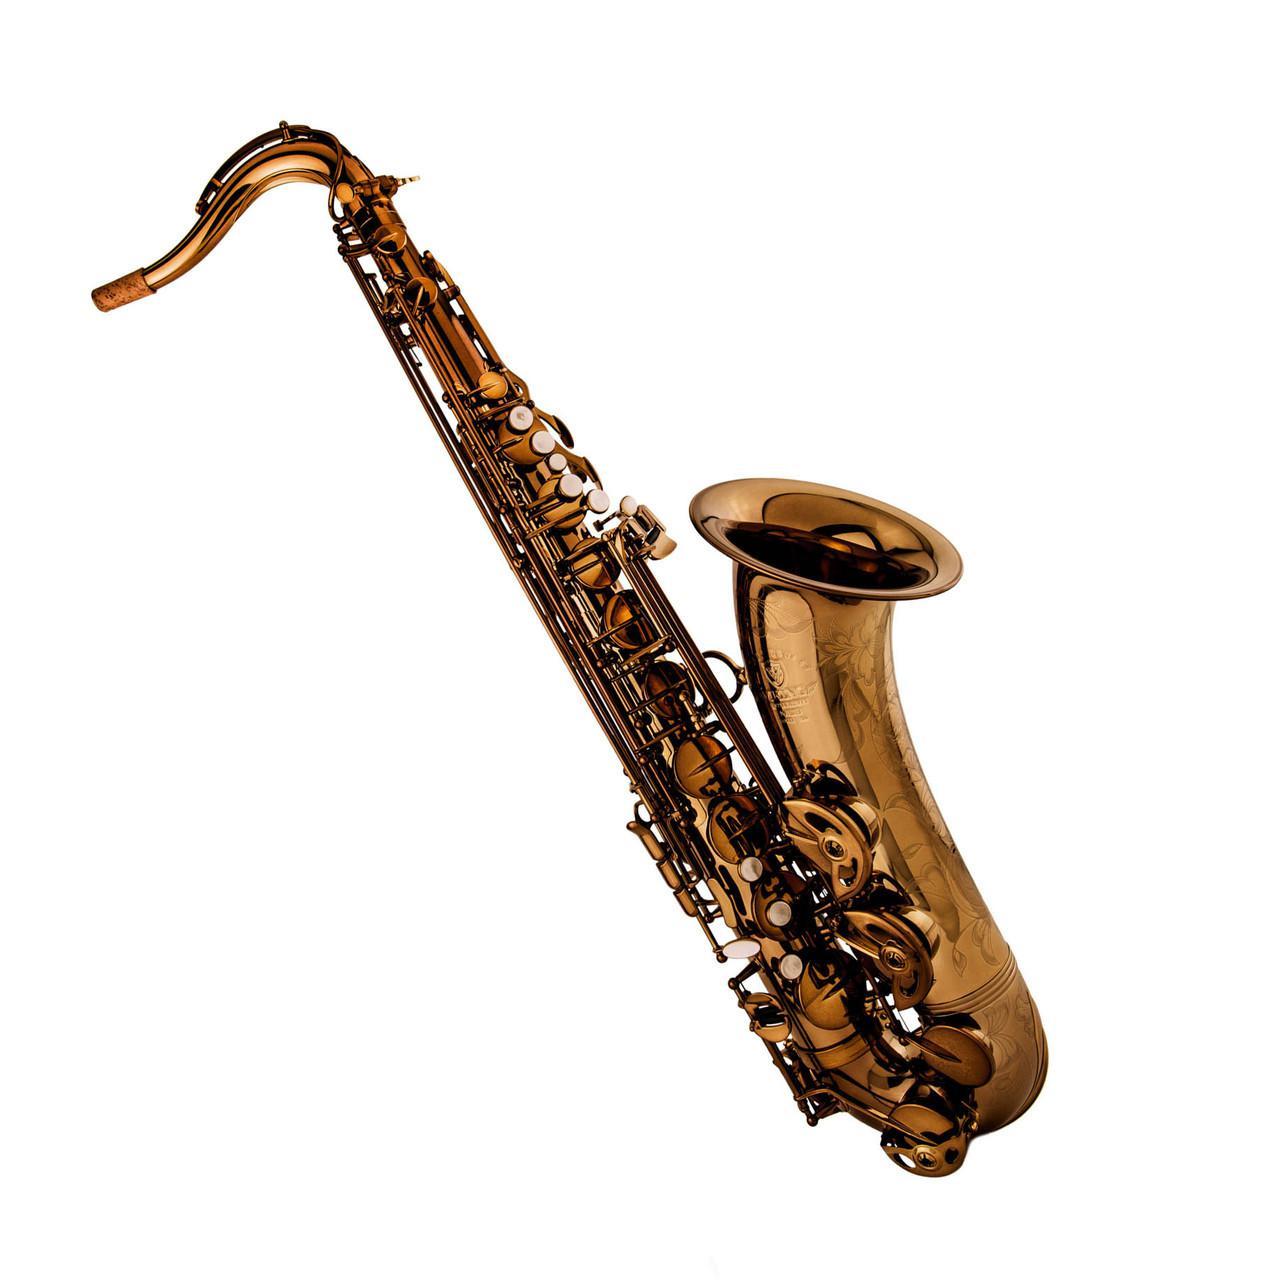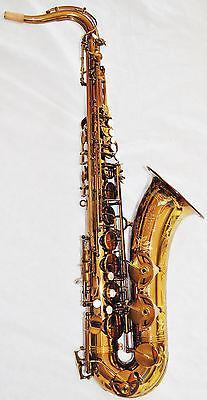The first image is the image on the left, the second image is the image on the right. For the images shown, is this caption "Each image contains an entire saxophone." true? Answer yes or no. Yes. 